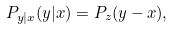<formula> <loc_0><loc_0><loc_500><loc_500>P _ { y | x } ( y | x ) = P _ { z } ( y - x ) ,</formula> 